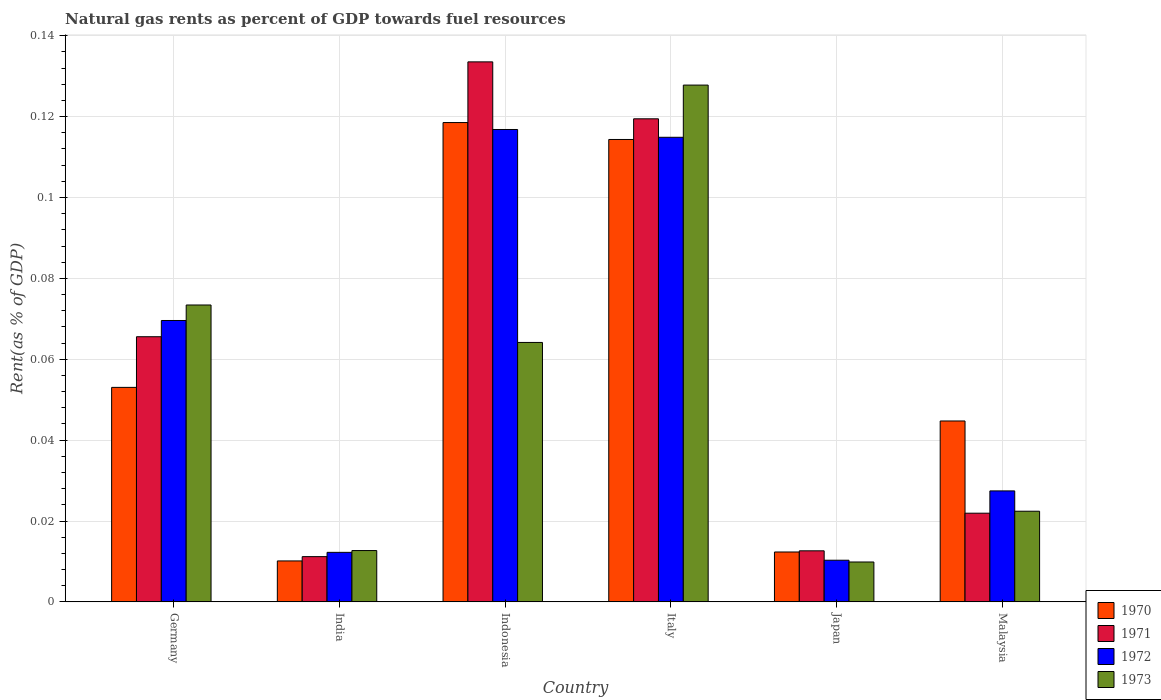How many different coloured bars are there?
Keep it short and to the point. 4. How many groups of bars are there?
Give a very brief answer. 6. Are the number of bars per tick equal to the number of legend labels?
Offer a terse response. Yes. How many bars are there on the 5th tick from the left?
Offer a terse response. 4. In how many cases, is the number of bars for a given country not equal to the number of legend labels?
Make the answer very short. 0. What is the matural gas rent in 1970 in Indonesia?
Keep it short and to the point. 0.12. Across all countries, what is the maximum matural gas rent in 1970?
Make the answer very short. 0.12. Across all countries, what is the minimum matural gas rent in 1973?
Make the answer very short. 0.01. What is the total matural gas rent in 1971 in the graph?
Your response must be concise. 0.36. What is the difference between the matural gas rent in 1972 in India and that in Italy?
Make the answer very short. -0.1. What is the difference between the matural gas rent in 1971 in Indonesia and the matural gas rent in 1970 in Germany?
Give a very brief answer. 0.08. What is the average matural gas rent in 1973 per country?
Provide a succinct answer. 0.05. What is the difference between the matural gas rent of/in 1973 and matural gas rent of/in 1970 in Malaysia?
Provide a succinct answer. -0.02. What is the ratio of the matural gas rent in 1971 in Germany to that in Malaysia?
Ensure brevity in your answer.  2.99. Is the difference between the matural gas rent in 1973 in Italy and Malaysia greater than the difference between the matural gas rent in 1970 in Italy and Malaysia?
Offer a terse response. Yes. What is the difference between the highest and the second highest matural gas rent in 1973?
Your answer should be very brief. 0.05. What is the difference between the highest and the lowest matural gas rent in 1970?
Your answer should be very brief. 0.11. Is it the case that in every country, the sum of the matural gas rent in 1973 and matural gas rent in 1971 is greater than the sum of matural gas rent in 1972 and matural gas rent in 1970?
Offer a very short reply. No. What does the 4th bar from the left in Italy represents?
Your answer should be compact. 1973. What does the 3rd bar from the right in India represents?
Your answer should be compact. 1971. How many bars are there?
Your answer should be compact. 24. Are all the bars in the graph horizontal?
Provide a short and direct response. No. How many countries are there in the graph?
Provide a succinct answer. 6. What is the difference between two consecutive major ticks on the Y-axis?
Provide a short and direct response. 0.02. Are the values on the major ticks of Y-axis written in scientific E-notation?
Offer a terse response. No. Does the graph contain any zero values?
Ensure brevity in your answer.  No. Does the graph contain grids?
Offer a very short reply. Yes. How many legend labels are there?
Your answer should be compact. 4. What is the title of the graph?
Make the answer very short. Natural gas rents as percent of GDP towards fuel resources. Does "1994" appear as one of the legend labels in the graph?
Provide a short and direct response. No. What is the label or title of the Y-axis?
Offer a very short reply. Rent(as % of GDP). What is the Rent(as % of GDP) in 1970 in Germany?
Provide a succinct answer. 0.05. What is the Rent(as % of GDP) in 1971 in Germany?
Your response must be concise. 0.07. What is the Rent(as % of GDP) in 1972 in Germany?
Make the answer very short. 0.07. What is the Rent(as % of GDP) in 1973 in Germany?
Make the answer very short. 0.07. What is the Rent(as % of GDP) in 1970 in India?
Your response must be concise. 0.01. What is the Rent(as % of GDP) of 1971 in India?
Your response must be concise. 0.01. What is the Rent(as % of GDP) in 1972 in India?
Offer a very short reply. 0.01. What is the Rent(as % of GDP) of 1973 in India?
Offer a terse response. 0.01. What is the Rent(as % of GDP) in 1970 in Indonesia?
Ensure brevity in your answer.  0.12. What is the Rent(as % of GDP) of 1971 in Indonesia?
Give a very brief answer. 0.13. What is the Rent(as % of GDP) of 1972 in Indonesia?
Keep it short and to the point. 0.12. What is the Rent(as % of GDP) of 1973 in Indonesia?
Provide a succinct answer. 0.06. What is the Rent(as % of GDP) in 1970 in Italy?
Ensure brevity in your answer.  0.11. What is the Rent(as % of GDP) of 1971 in Italy?
Keep it short and to the point. 0.12. What is the Rent(as % of GDP) of 1972 in Italy?
Your response must be concise. 0.11. What is the Rent(as % of GDP) of 1973 in Italy?
Offer a terse response. 0.13. What is the Rent(as % of GDP) in 1970 in Japan?
Ensure brevity in your answer.  0.01. What is the Rent(as % of GDP) in 1971 in Japan?
Provide a short and direct response. 0.01. What is the Rent(as % of GDP) in 1972 in Japan?
Ensure brevity in your answer.  0.01. What is the Rent(as % of GDP) of 1973 in Japan?
Make the answer very short. 0.01. What is the Rent(as % of GDP) in 1970 in Malaysia?
Provide a succinct answer. 0.04. What is the Rent(as % of GDP) of 1971 in Malaysia?
Ensure brevity in your answer.  0.02. What is the Rent(as % of GDP) in 1972 in Malaysia?
Ensure brevity in your answer.  0.03. What is the Rent(as % of GDP) of 1973 in Malaysia?
Your answer should be very brief. 0.02. Across all countries, what is the maximum Rent(as % of GDP) of 1970?
Give a very brief answer. 0.12. Across all countries, what is the maximum Rent(as % of GDP) in 1971?
Your response must be concise. 0.13. Across all countries, what is the maximum Rent(as % of GDP) in 1972?
Make the answer very short. 0.12. Across all countries, what is the maximum Rent(as % of GDP) in 1973?
Give a very brief answer. 0.13. Across all countries, what is the minimum Rent(as % of GDP) in 1970?
Make the answer very short. 0.01. Across all countries, what is the minimum Rent(as % of GDP) of 1971?
Your answer should be very brief. 0.01. Across all countries, what is the minimum Rent(as % of GDP) of 1972?
Ensure brevity in your answer.  0.01. Across all countries, what is the minimum Rent(as % of GDP) in 1973?
Make the answer very short. 0.01. What is the total Rent(as % of GDP) of 1970 in the graph?
Your answer should be very brief. 0.35. What is the total Rent(as % of GDP) of 1971 in the graph?
Give a very brief answer. 0.36. What is the total Rent(as % of GDP) in 1972 in the graph?
Ensure brevity in your answer.  0.35. What is the total Rent(as % of GDP) of 1973 in the graph?
Provide a short and direct response. 0.31. What is the difference between the Rent(as % of GDP) in 1970 in Germany and that in India?
Keep it short and to the point. 0.04. What is the difference between the Rent(as % of GDP) in 1971 in Germany and that in India?
Offer a very short reply. 0.05. What is the difference between the Rent(as % of GDP) in 1972 in Germany and that in India?
Your answer should be very brief. 0.06. What is the difference between the Rent(as % of GDP) in 1973 in Germany and that in India?
Your answer should be compact. 0.06. What is the difference between the Rent(as % of GDP) of 1970 in Germany and that in Indonesia?
Make the answer very short. -0.07. What is the difference between the Rent(as % of GDP) of 1971 in Germany and that in Indonesia?
Provide a succinct answer. -0.07. What is the difference between the Rent(as % of GDP) of 1972 in Germany and that in Indonesia?
Make the answer very short. -0.05. What is the difference between the Rent(as % of GDP) of 1973 in Germany and that in Indonesia?
Offer a terse response. 0.01. What is the difference between the Rent(as % of GDP) of 1970 in Germany and that in Italy?
Provide a short and direct response. -0.06. What is the difference between the Rent(as % of GDP) of 1971 in Germany and that in Italy?
Give a very brief answer. -0.05. What is the difference between the Rent(as % of GDP) of 1972 in Germany and that in Italy?
Provide a short and direct response. -0.05. What is the difference between the Rent(as % of GDP) of 1973 in Germany and that in Italy?
Make the answer very short. -0.05. What is the difference between the Rent(as % of GDP) of 1970 in Germany and that in Japan?
Ensure brevity in your answer.  0.04. What is the difference between the Rent(as % of GDP) in 1971 in Germany and that in Japan?
Offer a terse response. 0.05. What is the difference between the Rent(as % of GDP) in 1972 in Germany and that in Japan?
Give a very brief answer. 0.06. What is the difference between the Rent(as % of GDP) in 1973 in Germany and that in Japan?
Your response must be concise. 0.06. What is the difference between the Rent(as % of GDP) of 1970 in Germany and that in Malaysia?
Offer a terse response. 0.01. What is the difference between the Rent(as % of GDP) of 1971 in Germany and that in Malaysia?
Make the answer very short. 0.04. What is the difference between the Rent(as % of GDP) in 1972 in Germany and that in Malaysia?
Your answer should be compact. 0.04. What is the difference between the Rent(as % of GDP) in 1973 in Germany and that in Malaysia?
Make the answer very short. 0.05. What is the difference between the Rent(as % of GDP) in 1970 in India and that in Indonesia?
Provide a succinct answer. -0.11. What is the difference between the Rent(as % of GDP) in 1971 in India and that in Indonesia?
Provide a succinct answer. -0.12. What is the difference between the Rent(as % of GDP) in 1972 in India and that in Indonesia?
Your response must be concise. -0.1. What is the difference between the Rent(as % of GDP) in 1973 in India and that in Indonesia?
Make the answer very short. -0.05. What is the difference between the Rent(as % of GDP) in 1970 in India and that in Italy?
Keep it short and to the point. -0.1. What is the difference between the Rent(as % of GDP) of 1971 in India and that in Italy?
Ensure brevity in your answer.  -0.11. What is the difference between the Rent(as % of GDP) in 1972 in India and that in Italy?
Your response must be concise. -0.1. What is the difference between the Rent(as % of GDP) of 1973 in India and that in Italy?
Provide a short and direct response. -0.12. What is the difference between the Rent(as % of GDP) in 1970 in India and that in Japan?
Give a very brief answer. -0. What is the difference between the Rent(as % of GDP) in 1971 in India and that in Japan?
Offer a terse response. -0. What is the difference between the Rent(as % of GDP) of 1972 in India and that in Japan?
Offer a very short reply. 0. What is the difference between the Rent(as % of GDP) in 1973 in India and that in Japan?
Keep it short and to the point. 0. What is the difference between the Rent(as % of GDP) of 1970 in India and that in Malaysia?
Your answer should be compact. -0.03. What is the difference between the Rent(as % of GDP) of 1971 in India and that in Malaysia?
Your response must be concise. -0.01. What is the difference between the Rent(as % of GDP) of 1972 in India and that in Malaysia?
Offer a terse response. -0.02. What is the difference between the Rent(as % of GDP) in 1973 in India and that in Malaysia?
Provide a short and direct response. -0.01. What is the difference between the Rent(as % of GDP) of 1970 in Indonesia and that in Italy?
Give a very brief answer. 0. What is the difference between the Rent(as % of GDP) of 1971 in Indonesia and that in Italy?
Ensure brevity in your answer.  0.01. What is the difference between the Rent(as % of GDP) of 1972 in Indonesia and that in Italy?
Your answer should be compact. 0. What is the difference between the Rent(as % of GDP) of 1973 in Indonesia and that in Italy?
Offer a very short reply. -0.06. What is the difference between the Rent(as % of GDP) of 1970 in Indonesia and that in Japan?
Keep it short and to the point. 0.11. What is the difference between the Rent(as % of GDP) of 1971 in Indonesia and that in Japan?
Provide a succinct answer. 0.12. What is the difference between the Rent(as % of GDP) of 1972 in Indonesia and that in Japan?
Provide a succinct answer. 0.11. What is the difference between the Rent(as % of GDP) of 1973 in Indonesia and that in Japan?
Your response must be concise. 0.05. What is the difference between the Rent(as % of GDP) in 1970 in Indonesia and that in Malaysia?
Offer a terse response. 0.07. What is the difference between the Rent(as % of GDP) in 1971 in Indonesia and that in Malaysia?
Offer a terse response. 0.11. What is the difference between the Rent(as % of GDP) in 1972 in Indonesia and that in Malaysia?
Make the answer very short. 0.09. What is the difference between the Rent(as % of GDP) of 1973 in Indonesia and that in Malaysia?
Make the answer very short. 0.04. What is the difference between the Rent(as % of GDP) of 1970 in Italy and that in Japan?
Keep it short and to the point. 0.1. What is the difference between the Rent(as % of GDP) of 1971 in Italy and that in Japan?
Give a very brief answer. 0.11. What is the difference between the Rent(as % of GDP) of 1972 in Italy and that in Japan?
Keep it short and to the point. 0.1. What is the difference between the Rent(as % of GDP) in 1973 in Italy and that in Japan?
Make the answer very short. 0.12. What is the difference between the Rent(as % of GDP) in 1970 in Italy and that in Malaysia?
Ensure brevity in your answer.  0.07. What is the difference between the Rent(as % of GDP) in 1971 in Italy and that in Malaysia?
Your answer should be compact. 0.1. What is the difference between the Rent(as % of GDP) in 1972 in Italy and that in Malaysia?
Offer a terse response. 0.09. What is the difference between the Rent(as % of GDP) in 1973 in Italy and that in Malaysia?
Your answer should be compact. 0.11. What is the difference between the Rent(as % of GDP) of 1970 in Japan and that in Malaysia?
Keep it short and to the point. -0.03. What is the difference between the Rent(as % of GDP) in 1971 in Japan and that in Malaysia?
Your answer should be very brief. -0.01. What is the difference between the Rent(as % of GDP) of 1972 in Japan and that in Malaysia?
Your response must be concise. -0.02. What is the difference between the Rent(as % of GDP) in 1973 in Japan and that in Malaysia?
Make the answer very short. -0.01. What is the difference between the Rent(as % of GDP) in 1970 in Germany and the Rent(as % of GDP) in 1971 in India?
Your response must be concise. 0.04. What is the difference between the Rent(as % of GDP) in 1970 in Germany and the Rent(as % of GDP) in 1972 in India?
Your answer should be compact. 0.04. What is the difference between the Rent(as % of GDP) of 1970 in Germany and the Rent(as % of GDP) of 1973 in India?
Offer a very short reply. 0.04. What is the difference between the Rent(as % of GDP) of 1971 in Germany and the Rent(as % of GDP) of 1972 in India?
Ensure brevity in your answer.  0.05. What is the difference between the Rent(as % of GDP) in 1971 in Germany and the Rent(as % of GDP) in 1973 in India?
Your answer should be compact. 0.05. What is the difference between the Rent(as % of GDP) in 1972 in Germany and the Rent(as % of GDP) in 1973 in India?
Your answer should be compact. 0.06. What is the difference between the Rent(as % of GDP) of 1970 in Germany and the Rent(as % of GDP) of 1971 in Indonesia?
Give a very brief answer. -0.08. What is the difference between the Rent(as % of GDP) in 1970 in Germany and the Rent(as % of GDP) in 1972 in Indonesia?
Your answer should be compact. -0.06. What is the difference between the Rent(as % of GDP) of 1970 in Germany and the Rent(as % of GDP) of 1973 in Indonesia?
Your answer should be very brief. -0.01. What is the difference between the Rent(as % of GDP) in 1971 in Germany and the Rent(as % of GDP) in 1972 in Indonesia?
Provide a succinct answer. -0.05. What is the difference between the Rent(as % of GDP) of 1971 in Germany and the Rent(as % of GDP) of 1973 in Indonesia?
Keep it short and to the point. 0. What is the difference between the Rent(as % of GDP) of 1972 in Germany and the Rent(as % of GDP) of 1973 in Indonesia?
Offer a very short reply. 0.01. What is the difference between the Rent(as % of GDP) in 1970 in Germany and the Rent(as % of GDP) in 1971 in Italy?
Offer a very short reply. -0.07. What is the difference between the Rent(as % of GDP) in 1970 in Germany and the Rent(as % of GDP) in 1972 in Italy?
Ensure brevity in your answer.  -0.06. What is the difference between the Rent(as % of GDP) in 1970 in Germany and the Rent(as % of GDP) in 1973 in Italy?
Offer a very short reply. -0.07. What is the difference between the Rent(as % of GDP) in 1971 in Germany and the Rent(as % of GDP) in 1972 in Italy?
Keep it short and to the point. -0.05. What is the difference between the Rent(as % of GDP) of 1971 in Germany and the Rent(as % of GDP) of 1973 in Italy?
Your response must be concise. -0.06. What is the difference between the Rent(as % of GDP) in 1972 in Germany and the Rent(as % of GDP) in 1973 in Italy?
Give a very brief answer. -0.06. What is the difference between the Rent(as % of GDP) in 1970 in Germany and the Rent(as % of GDP) in 1971 in Japan?
Provide a succinct answer. 0.04. What is the difference between the Rent(as % of GDP) of 1970 in Germany and the Rent(as % of GDP) of 1972 in Japan?
Provide a short and direct response. 0.04. What is the difference between the Rent(as % of GDP) in 1970 in Germany and the Rent(as % of GDP) in 1973 in Japan?
Your response must be concise. 0.04. What is the difference between the Rent(as % of GDP) in 1971 in Germany and the Rent(as % of GDP) in 1972 in Japan?
Keep it short and to the point. 0.06. What is the difference between the Rent(as % of GDP) of 1971 in Germany and the Rent(as % of GDP) of 1973 in Japan?
Provide a short and direct response. 0.06. What is the difference between the Rent(as % of GDP) of 1972 in Germany and the Rent(as % of GDP) of 1973 in Japan?
Offer a terse response. 0.06. What is the difference between the Rent(as % of GDP) in 1970 in Germany and the Rent(as % of GDP) in 1971 in Malaysia?
Keep it short and to the point. 0.03. What is the difference between the Rent(as % of GDP) in 1970 in Germany and the Rent(as % of GDP) in 1972 in Malaysia?
Keep it short and to the point. 0.03. What is the difference between the Rent(as % of GDP) of 1970 in Germany and the Rent(as % of GDP) of 1973 in Malaysia?
Ensure brevity in your answer.  0.03. What is the difference between the Rent(as % of GDP) in 1971 in Germany and the Rent(as % of GDP) in 1972 in Malaysia?
Your answer should be compact. 0.04. What is the difference between the Rent(as % of GDP) of 1971 in Germany and the Rent(as % of GDP) of 1973 in Malaysia?
Give a very brief answer. 0.04. What is the difference between the Rent(as % of GDP) of 1972 in Germany and the Rent(as % of GDP) of 1973 in Malaysia?
Make the answer very short. 0.05. What is the difference between the Rent(as % of GDP) of 1970 in India and the Rent(as % of GDP) of 1971 in Indonesia?
Provide a short and direct response. -0.12. What is the difference between the Rent(as % of GDP) in 1970 in India and the Rent(as % of GDP) in 1972 in Indonesia?
Offer a terse response. -0.11. What is the difference between the Rent(as % of GDP) in 1970 in India and the Rent(as % of GDP) in 1973 in Indonesia?
Make the answer very short. -0.05. What is the difference between the Rent(as % of GDP) of 1971 in India and the Rent(as % of GDP) of 1972 in Indonesia?
Provide a short and direct response. -0.11. What is the difference between the Rent(as % of GDP) of 1971 in India and the Rent(as % of GDP) of 1973 in Indonesia?
Offer a very short reply. -0.05. What is the difference between the Rent(as % of GDP) in 1972 in India and the Rent(as % of GDP) in 1973 in Indonesia?
Make the answer very short. -0.05. What is the difference between the Rent(as % of GDP) in 1970 in India and the Rent(as % of GDP) in 1971 in Italy?
Your response must be concise. -0.11. What is the difference between the Rent(as % of GDP) of 1970 in India and the Rent(as % of GDP) of 1972 in Italy?
Your response must be concise. -0.1. What is the difference between the Rent(as % of GDP) in 1970 in India and the Rent(as % of GDP) in 1973 in Italy?
Give a very brief answer. -0.12. What is the difference between the Rent(as % of GDP) of 1971 in India and the Rent(as % of GDP) of 1972 in Italy?
Your answer should be compact. -0.1. What is the difference between the Rent(as % of GDP) of 1971 in India and the Rent(as % of GDP) of 1973 in Italy?
Your answer should be very brief. -0.12. What is the difference between the Rent(as % of GDP) in 1972 in India and the Rent(as % of GDP) in 1973 in Italy?
Your response must be concise. -0.12. What is the difference between the Rent(as % of GDP) of 1970 in India and the Rent(as % of GDP) of 1971 in Japan?
Give a very brief answer. -0. What is the difference between the Rent(as % of GDP) of 1970 in India and the Rent(as % of GDP) of 1972 in Japan?
Ensure brevity in your answer.  -0. What is the difference between the Rent(as % of GDP) of 1971 in India and the Rent(as % of GDP) of 1972 in Japan?
Your answer should be very brief. 0. What is the difference between the Rent(as % of GDP) of 1971 in India and the Rent(as % of GDP) of 1973 in Japan?
Make the answer very short. 0. What is the difference between the Rent(as % of GDP) in 1972 in India and the Rent(as % of GDP) in 1973 in Japan?
Your answer should be very brief. 0. What is the difference between the Rent(as % of GDP) in 1970 in India and the Rent(as % of GDP) in 1971 in Malaysia?
Offer a very short reply. -0.01. What is the difference between the Rent(as % of GDP) in 1970 in India and the Rent(as % of GDP) in 1972 in Malaysia?
Your answer should be compact. -0.02. What is the difference between the Rent(as % of GDP) of 1970 in India and the Rent(as % of GDP) of 1973 in Malaysia?
Your response must be concise. -0.01. What is the difference between the Rent(as % of GDP) of 1971 in India and the Rent(as % of GDP) of 1972 in Malaysia?
Keep it short and to the point. -0.02. What is the difference between the Rent(as % of GDP) of 1971 in India and the Rent(as % of GDP) of 1973 in Malaysia?
Offer a terse response. -0.01. What is the difference between the Rent(as % of GDP) of 1972 in India and the Rent(as % of GDP) of 1973 in Malaysia?
Ensure brevity in your answer.  -0.01. What is the difference between the Rent(as % of GDP) of 1970 in Indonesia and the Rent(as % of GDP) of 1971 in Italy?
Offer a terse response. -0. What is the difference between the Rent(as % of GDP) of 1970 in Indonesia and the Rent(as % of GDP) of 1972 in Italy?
Offer a very short reply. 0. What is the difference between the Rent(as % of GDP) in 1970 in Indonesia and the Rent(as % of GDP) in 1973 in Italy?
Your answer should be very brief. -0.01. What is the difference between the Rent(as % of GDP) of 1971 in Indonesia and the Rent(as % of GDP) of 1972 in Italy?
Your response must be concise. 0.02. What is the difference between the Rent(as % of GDP) of 1971 in Indonesia and the Rent(as % of GDP) of 1973 in Italy?
Provide a succinct answer. 0.01. What is the difference between the Rent(as % of GDP) of 1972 in Indonesia and the Rent(as % of GDP) of 1973 in Italy?
Provide a short and direct response. -0.01. What is the difference between the Rent(as % of GDP) in 1970 in Indonesia and the Rent(as % of GDP) in 1971 in Japan?
Your response must be concise. 0.11. What is the difference between the Rent(as % of GDP) in 1970 in Indonesia and the Rent(as % of GDP) in 1972 in Japan?
Keep it short and to the point. 0.11. What is the difference between the Rent(as % of GDP) of 1970 in Indonesia and the Rent(as % of GDP) of 1973 in Japan?
Provide a succinct answer. 0.11. What is the difference between the Rent(as % of GDP) in 1971 in Indonesia and the Rent(as % of GDP) in 1972 in Japan?
Your answer should be compact. 0.12. What is the difference between the Rent(as % of GDP) of 1971 in Indonesia and the Rent(as % of GDP) of 1973 in Japan?
Your response must be concise. 0.12. What is the difference between the Rent(as % of GDP) of 1972 in Indonesia and the Rent(as % of GDP) of 1973 in Japan?
Your response must be concise. 0.11. What is the difference between the Rent(as % of GDP) in 1970 in Indonesia and the Rent(as % of GDP) in 1971 in Malaysia?
Provide a short and direct response. 0.1. What is the difference between the Rent(as % of GDP) of 1970 in Indonesia and the Rent(as % of GDP) of 1972 in Malaysia?
Provide a succinct answer. 0.09. What is the difference between the Rent(as % of GDP) of 1970 in Indonesia and the Rent(as % of GDP) of 1973 in Malaysia?
Offer a terse response. 0.1. What is the difference between the Rent(as % of GDP) of 1971 in Indonesia and the Rent(as % of GDP) of 1972 in Malaysia?
Your response must be concise. 0.11. What is the difference between the Rent(as % of GDP) of 1972 in Indonesia and the Rent(as % of GDP) of 1973 in Malaysia?
Provide a succinct answer. 0.09. What is the difference between the Rent(as % of GDP) in 1970 in Italy and the Rent(as % of GDP) in 1971 in Japan?
Your answer should be very brief. 0.1. What is the difference between the Rent(as % of GDP) in 1970 in Italy and the Rent(as % of GDP) in 1972 in Japan?
Ensure brevity in your answer.  0.1. What is the difference between the Rent(as % of GDP) of 1970 in Italy and the Rent(as % of GDP) of 1973 in Japan?
Your answer should be compact. 0.1. What is the difference between the Rent(as % of GDP) of 1971 in Italy and the Rent(as % of GDP) of 1972 in Japan?
Offer a terse response. 0.11. What is the difference between the Rent(as % of GDP) of 1971 in Italy and the Rent(as % of GDP) of 1973 in Japan?
Ensure brevity in your answer.  0.11. What is the difference between the Rent(as % of GDP) of 1972 in Italy and the Rent(as % of GDP) of 1973 in Japan?
Provide a short and direct response. 0.1. What is the difference between the Rent(as % of GDP) in 1970 in Italy and the Rent(as % of GDP) in 1971 in Malaysia?
Your response must be concise. 0.09. What is the difference between the Rent(as % of GDP) in 1970 in Italy and the Rent(as % of GDP) in 1972 in Malaysia?
Give a very brief answer. 0.09. What is the difference between the Rent(as % of GDP) in 1970 in Italy and the Rent(as % of GDP) in 1973 in Malaysia?
Provide a succinct answer. 0.09. What is the difference between the Rent(as % of GDP) in 1971 in Italy and the Rent(as % of GDP) in 1972 in Malaysia?
Provide a short and direct response. 0.09. What is the difference between the Rent(as % of GDP) in 1971 in Italy and the Rent(as % of GDP) in 1973 in Malaysia?
Your answer should be very brief. 0.1. What is the difference between the Rent(as % of GDP) of 1972 in Italy and the Rent(as % of GDP) of 1973 in Malaysia?
Offer a very short reply. 0.09. What is the difference between the Rent(as % of GDP) of 1970 in Japan and the Rent(as % of GDP) of 1971 in Malaysia?
Offer a very short reply. -0.01. What is the difference between the Rent(as % of GDP) in 1970 in Japan and the Rent(as % of GDP) in 1972 in Malaysia?
Offer a very short reply. -0.02. What is the difference between the Rent(as % of GDP) of 1970 in Japan and the Rent(as % of GDP) of 1973 in Malaysia?
Give a very brief answer. -0.01. What is the difference between the Rent(as % of GDP) in 1971 in Japan and the Rent(as % of GDP) in 1972 in Malaysia?
Ensure brevity in your answer.  -0.01. What is the difference between the Rent(as % of GDP) in 1971 in Japan and the Rent(as % of GDP) in 1973 in Malaysia?
Make the answer very short. -0.01. What is the difference between the Rent(as % of GDP) of 1972 in Japan and the Rent(as % of GDP) of 1973 in Malaysia?
Give a very brief answer. -0.01. What is the average Rent(as % of GDP) in 1970 per country?
Provide a succinct answer. 0.06. What is the average Rent(as % of GDP) of 1971 per country?
Keep it short and to the point. 0.06. What is the average Rent(as % of GDP) in 1972 per country?
Ensure brevity in your answer.  0.06. What is the average Rent(as % of GDP) in 1973 per country?
Ensure brevity in your answer.  0.05. What is the difference between the Rent(as % of GDP) of 1970 and Rent(as % of GDP) of 1971 in Germany?
Provide a succinct answer. -0.01. What is the difference between the Rent(as % of GDP) in 1970 and Rent(as % of GDP) in 1972 in Germany?
Offer a terse response. -0.02. What is the difference between the Rent(as % of GDP) of 1970 and Rent(as % of GDP) of 1973 in Germany?
Provide a succinct answer. -0.02. What is the difference between the Rent(as % of GDP) in 1971 and Rent(as % of GDP) in 1972 in Germany?
Your response must be concise. -0. What is the difference between the Rent(as % of GDP) in 1971 and Rent(as % of GDP) in 1973 in Germany?
Offer a very short reply. -0.01. What is the difference between the Rent(as % of GDP) in 1972 and Rent(as % of GDP) in 1973 in Germany?
Give a very brief answer. -0. What is the difference between the Rent(as % of GDP) in 1970 and Rent(as % of GDP) in 1971 in India?
Make the answer very short. -0. What is the difference between the Rent(as % of GDP) in 1970 and Rent(as % of GDP) in 1972 in India?
Keep it short and to the point. -0. What is the difference between the Rent(as % of GDP) of 1970 and Rent(as % of GDP) of 1973 in India?
Your response must be concise. -0. What is the difference between the Rent(as % of GDP) of 1971 and Rent(as % of GDP) of 1972 in India?
Offer a terse response. -0. What is the difference between the Rent(as % of GDP) of 1971 and Rent(as % of GDP) of 1973 in India?
Give a very brief answer. -0. What is the difference between the Rent(as % of GDP) of 1972 and Rent(as % of GDP) of 1973 in India?
Provide a succinct answer. -0. What is the difference between the Rent(as % of GDP) of 1970 and Rent(as % of GDP) of 1971 in Indonesia?
Offer a terse response. -0.01. What is the difference between the Rent(as % of GDP) of 1970 and Rent(as % of GDP) of 1972 in Indonesia?
Make the answer very short. 0. What is the difference between the Rent(as % of GDP) of 1970 and Rent(as % of GDP) of 1973 in Indonesia?
Ensure brevity in your answer.  0.05. What is the difference between the Rent(as % of GDP) of 1971 and Rent(as % of GDP) of 1972 in Indonesia?
Provide a succinct answer. 0.02. What is the difference between the Rent(as % of GDP) in 1971 and Rent(as % of GDP) in 1973 in Indonesia?
Keep it short and to the point. 0.07. What is the difference between the Rent(as % of GDP) in 1972 and Rent(as % of GDP) in 1973 in Indonesia?
Make the answer very short. 0.05. What is the difference between the Rent(as % of GDP) in 1970 and Rent(as % of GDP) in 1971 in Italy?
Offer a terse response. -0.01. What is the difference between the Rent(as % of GDP) of 1970 and Rent(as % of GDP) of 1972 in Italy?
Keep it short and to the point. -0. What is the difference between the Rent(as % of GDP) in 1970 and Rent(as % of GDP) in 1973 in Italy?
Your response must be concise. -0.01. What is the difference between the Rent(as % of GDP) in 1971 and Rent(as % of GDP) in 1972 in Italy?
Your answer should be compact. 0. What is the difference between the Rent(as % of GDP) in 1971 and Rent(as % of GDP) in 1973 in Italy?
Ensure brevity in your answer.  -0.01. What is the difference between the Rent(as % of GDP) in 1972 and Rent(as % of GDP) in 1973 in Italy?
Provide a succinct answer. -0.01. What is the difference between the Rent(as % of GDP) of 1970 and Rent(as % of GDP) of 1971 in Japan?
Offer a very short reply. -0. What is the difference between the Rent(as % of GDP) of 1970 and Rent(as % of GDP) of 1972 in Japan?
Give a very brief answer. 0. What is the difference between the Rent(as % of GDP) of 1970 and Rent(as % of GDP) of 1973 in Japan?
Give a very brief answer. 0. What is the difference between the Rent(as % of GDP) of 1971 and Rent(as % of GDP) of 1972 in Japan?
Keep it short and to the point. 0. What is the difference between the Rent(as % of GDP) of 1971 and Rent(as % of GDP) of 1973 in Japan?
Provide a succinct answer. 0. What is the difference between the Rent(as % of GDP) in 1972 and Rent(as % of GDP) in 1973 in Japan?
Offer a terse response. 0. What is the difference between the Rent(as % of GDP) in 1970 and Rent(as % of GDP) in 1971 in Malaysia?
Ensure brevity in your answer.  0.02. What is the difference between the Rent(as % of GDP) in 1970 and Rent(as % of GDP) in 1972 in Malaysia?
Make the answer very short. 0.02. What is the difference between the Rent(as % of GDP) of 1970 and Rent(as % of GDP) of 1973 in Malaysia?
Provide a succinct answer. 0.02. What is the difference between the Rent(as % of GDP) of 1971 and Rent(as % of GDP) of 1972 in Malaysia?
Offer a very short reply. -0.01. What is the difference between the Rent(as % of GDP) of 1971 and Rent(as % of GDP) of 1973 in Malaysia?
Offer a very short reply. -0. What is the difference between the Rent(as % of GDP) of 1972 and Rent(as % of GDP) of 1973 in Malaysia?
Give a very brief answer. 0.01. What is the ratio of the Rent(as % of GDP) of 1970 in Germany to that in India?
Your answer should be compact. 5.24. What is the ratio of the Rent(as % of GDP) in 1971 in Germany to that in India?
Ensure brevity in your answer.  5.86. What is the ratio of the Rent(as % of GDP) of 1972 in Germany to that in India?
Your response must be concise. 5.68. What is the ratio of the Rent(as % of GDP) of 1973 in Germany to that in India?
Offer a terse response. 5.79. What is the ratio of the Rent(as % of GDP) in 1970 in Germany to that in Indonesia?
Keep it short and to the point. 0.45. What is the ratio of the Rent(as % of GDP) in 1971 in Germany to that in Indonesia?
Provide a short and direct response. 0.49. What is the ratio of the Rent(as % of GDP) in 1972 in Germany to that in Indonesia?
Offer a very short reply. 0.6. What is the ratio of the Rent(as % of GDP) of 1973 in Germany to that in Indonesia?
Give a very brief answer. 1.14. What is the ratio of the Rent(as % of GDP) in 1970 in Germany to that in Italy?
Ensure brevity in your answer.  0.46. What is the ratio of the Rent(as % of GDP) of 1971 in Germany to that in Italy?
Offer a very short reply. 0.55. What is the ratio of the Rent(as % of GDP) in 1972 in Germany to that in Italy?
Your response must be concise. 0.61. What is the ratio of the Rent(as % of GDP) of 1973 in Germany to that in Italy?
Your answer should be very brief. 0.57. What is the ratio of the Rent(as % of GDP) in 1970 in Germany to that in Japan?
Provide a short and direct response. 4.3. What is the ratio of the Rent(as % of GDP) in 1971 in Germany to that in Japan?
Your answer should be compact. 5.19. What is the ratio of the Rent(as % of GDP) of 1972 in Germany to that in Japan?
Offer a very short reply. 6.76. What is the ratio of the Rent(as % of GDP) in 1973 in Germany to that in Japan?
Your answer should be compact. 7.44. What is the ratio of the Rent(as % of GDP) in 1970 in Germany to that in Malaysia?
Your answer should be very brief. 1.19. What is the ratio of the Rent(as % of GDP) in 1971 in Germany to that in Malaysia?
Ensure brevity in your answer.  2.99. What is the ratio of the Rent(as % of GDP) in 1972 in Germany to that in Malaysia?
Provide a succinct answer. 2.54. What is the ratio of the Rent(as % of GDP) in 1973 in Germany to that in Malaysia?
Ensure brevity in your answer.  3.27. What is the ratio of the Rent(as % of GDP) in 1970 in India to that in Indonesia?
Give a very brief answer. 0.09. What is the ratio of the Rent(as % of GDP) in 1971 in India to that in Indonesia?
Give a very brief answer. 0.08. What is the ratio of the Rent(as % of GDP) in 1972 in India to that in Indonesia?
Provide a succinct answer. 0.1. What is the ratio of the Rent(as % of GDP) of 1973 in India to that in Indonesia?
Offer a very short reply. 0.2. What is the ratio of the Rent(as % of GDP) of 1970 in India to that in Italy?
Offer a terse response. 0.09. What is the ratio of the Rent(as % of GDP) of 1971 in India to that in Italy?
Keep it short and to the point. 0.09. What is the ratio of the Rent(as % of GDP) in 1972 in India to that in Italy?
Provide a short and direct response. 0.11. What is the ratio of the Rent(as % of GDP) in 1973 in India to that in Italy?
Offer a terse response. 0.1. What is the ratio of the Rent(as % of GDP) of 1970 in India to that in Japan?
Your answer should be compact. 0.82. What is the ratio of the Rent(as % of GDP) of 1971 in India to that in Japan?
Provide a short and direct response. 0.89. What is the ratio of the Rent(as % of GDP) of 1972 in India to that in Japan?
Give a very brief answer. 1.19. What is the ratio of the Rent(as % of GDP) in 1973 in India to that in Japan?
Ensure brevity in your answer.  1.29. What is the ratio of the Rent(as % of GDP) in 1970 in India to that in Malaysia?
Offer a terse response. 0.23. What is the ratio of the Rent(as % of GDP) in 1971 in India to that in Malaysia?
Provide a succinct answer. 0.51. What is the ratio of the Rent(as % of GDP) of 1972 in India to that in Malaysia?
Keep it short and to the point. 0.45. What is the ratio of the Rent(as % of GDP) in 1973 in India to that in Malaysia?
Your response must be concise. 0.57. What is the ratio of the Rent(as % of GDP) of 1970 in Indonesia to that in Italy?
Your answer should be compact. 1.04. What is the ratio of the Rent(as % of GDP) of 1971 in Indonesia to that in Italy?
Offer a terse response. 1.12. What is the ratio of the Rent(as % of GDP) in 1972 in Indonesia to that in Italy?
Provide a succinct answer. 1.02. What is the ratio of the Rent(as % of GDP) in 1973 in Indonesia to that in Italy?
Provide a short and direct response. 0.5. What is the ratio of the Rent(as % of GDP) in 1970 in Indonesia to that in Japan?
Keep it short and to the point. 9.61. What is the ratio of the Rent(as % of GDP) of 1971 in Indonesia to that in Japan?
Offer a very short reply. 10.58. What is the ratio of the Rent(as % of GDP) in 1972 in Indonesia to that in Japan?
Keep it short and to the point. 11.34. What is the ratio of the Rent(as % of GDP) in 1973 in Indonesia to that in Japan?
Make the answer very short. 6.5. What is the ratio of the Rent(as % of GDP) in 1970 in Indonesia to that in Malaysia?
Give a very brief answer. 2.65. What is the ratio of the Rent(as % of GDP) in 1971 in Indonesia to that in Malaysia?
Ensure brevity in your answer.  6.09. What is the ratio of the Rent(as % of GDP) in 1972 in Indonesia to that in Malaysia?
Offer a terse response. 4.26. What is the ratio of the Rent(as % of GDP) in 1973 in Indonesia to that in Malaysia?
Ensure brevity in your answer.  2.86. What is the ratio of the Rent(as % of GDP) in 1970 in Italy to that in Japan?
Your answer should be very brief. 9.27. What is the ratio of the Rent(as % of GDP) in 1971 in Italy to that in Japan?
Ensure brevity in your answer.  9.46. What is the ratio of the Rent(as % of GDP) in 1972 in Italy to that in Japan?
Your answer should be compact. 11.16. What is the ratio of the Rent(as % of GDP) of 1973 in Italy to that in Japan?
Offer a terse response. 12.96. What is the ratio of the Rent(as % of GDP) of 1970 in Italy to that in Malaysia?
Ensure brevity in your answer.  2.56. What is the ratio of the Rent(as % of GDP) of 1971 in Italy to that in Malaysia?
Ensure brevity in your answer.  5.45. What is the ratio of the Rent(as % of GDP) of 1972 in Italy to that in Malaysia?
Your answer should be very brief. 4.19. What is the ratio of the Rent(as % of GDP) in 1973 in Italy to that in Malaysia?
Ensure brevity in your answer.  5.7. What is the ratio of the Rent(as % of GDP) of 1970 in Japan to that in Malaysia?
Offer a very short reply. 0.28. What is the ratio of the Rent(as % of GDP) of 1971 in Japan to that in Malaysia?
Give a very brief answer. 0.58. What is the ratio of the Rent(as % of GDP) in 1972 in Japan to that in Malaysia?
Give a very brief answer. 0.38. What is the ratio of the Rent(as % of GDP) of 1973 in Japan to that in Malaysia?
Your answer should be compact. 0.44. What is the difference between the highest and the second highest Rent(as % of GDP) of 1970?
Offer a very short reply. 0. What is the difference between the highest and the second highest Rent(as % of GDP) in 1971?
Your answer should be compact. 0.01. What is the difference between the highest and the second highest Rent(as % of GDP) of 1972?
Provide a succinct answer. 0. What is the difference between the highest and the second highest Rent(as % of GDP) of 1973?
Provide a short and direct response. 0.05. What is the difference between the highest and the lowest Rent(as % of GDP) in 1970?
Make the answer very short. 0.11. What is the difference between the highest and the lowest Rent(as % of GDP) of 1971?
Give a very brief answer. 0.12. What is the difference between the highest and the lowest Rent(as % of GDP) of 1972?
Your answer should be very brief. 0.11. What is the difference between the highest and the lowest Rent(as % of GDP) of 1973?
Provide a short and direct response. 0.12. 